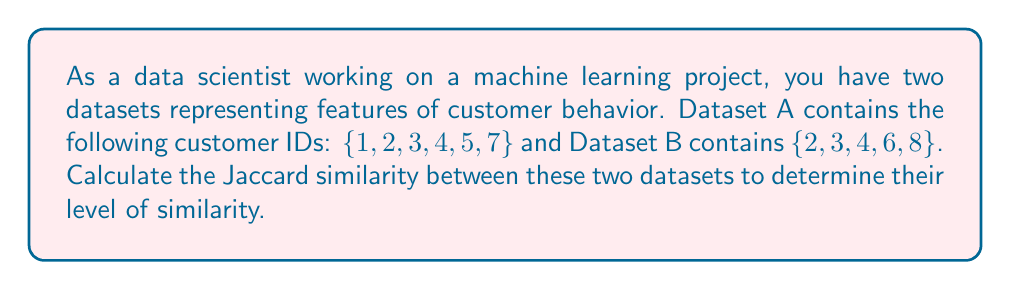What is the answer to this math problem? To calculate the Jaccard similarity between two datasets, we need to follow these steps:

1. Determine the intersection of the two datasets:
   The intersection of A and B is the set of elements that are common to both datasets.
   $A \cap B = \{2, 3, 4\}$

2. Determine the union of the two datasets:
   The union of A and B is the set of all unique elements from both datasets.
   $A \cup B = \{1, 2, 3, 4, 5, 6, 7, 8\}$

3. Calculate the Jaccard similarity using the formula:
   $J(A,B) = \frac{|A \cap B|}{|A \cup B|}$

   Where $|A \cap B|$ is the number of elements in the intersection and $|A \cup B|$ is the number of elements in the union.

4. Plug in the values:
   $J(A,B) = \frac{3}{8}$

5. Simplify the fraction:
   $J(A,B) = 0.375$

The Jaccard similarity ranges from 0 to 1, where 0 indicates no similarity and 1 indicates identical sets. A similarity of 0.375 suggests that the datasets have some overlap but are not highly similar.
Answer: The Jaccard similarity between Dataset A and Dataset B is $0.375$ or $\frac{3}{8}$. 